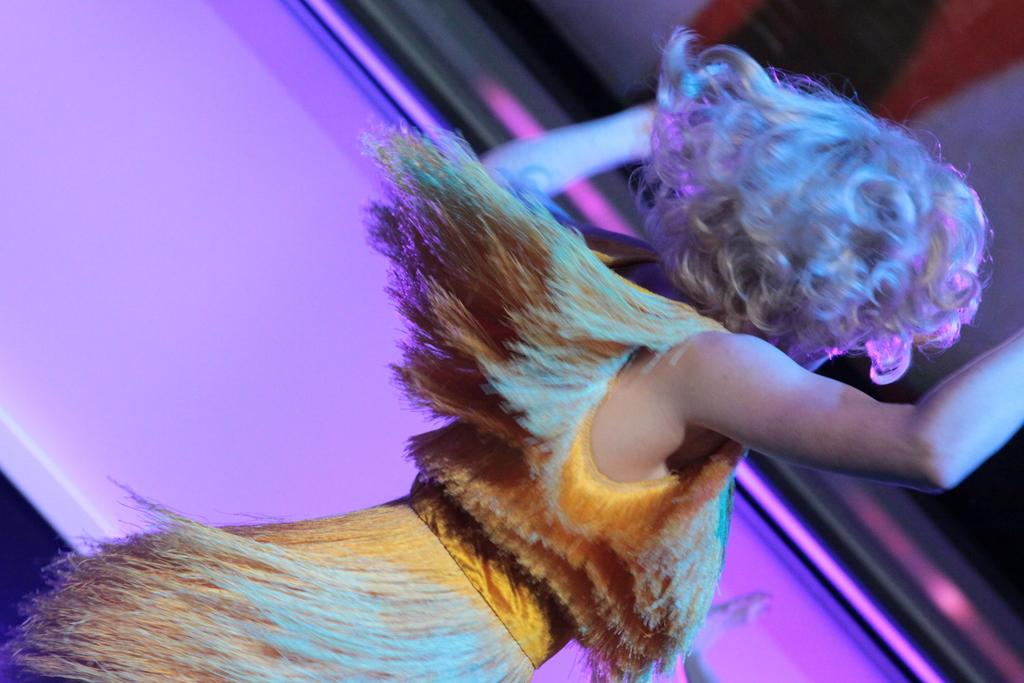Who is the main subject in the image? There is a woman in the image. What is the woman doing in the image? The woman is dancing. What color is the background in the image? The background in the image is pink. What type of religion is the woman practicing in the image? There is no indication of any religious practice in the image; it simply shows a woman dancing in front of a pink background. 